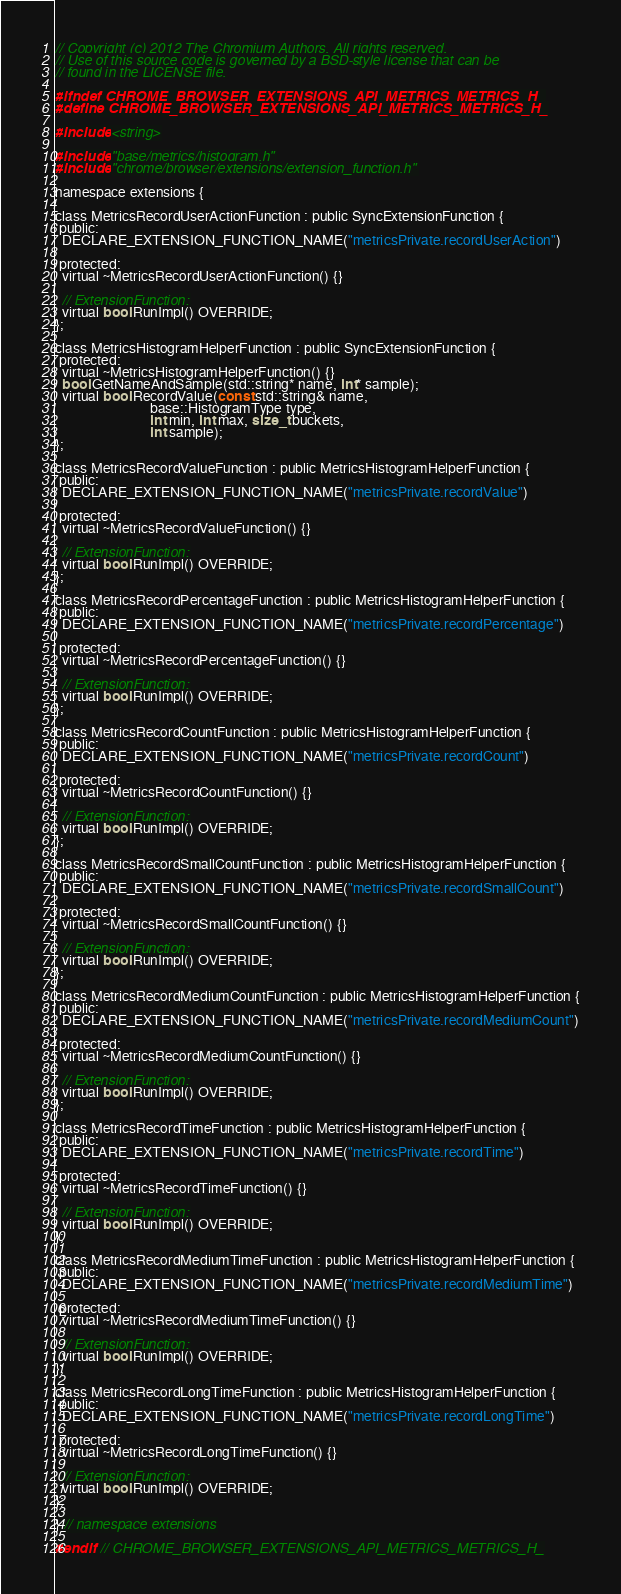Convert code to text. <code><loc_0><loc_0><loc_500><loc_500><_C_>// Copyright (c) 2012 The Chromium Authors. All rights reserved.
// Use of this source code is governed by a BSD-style license that can be
// found in the LICENSE file.

#ifndef CHROME_BROWSER_EXTENSIONS_API_METRICS_METRICS_H_
#define CHROME_BROWSER_EXTENSIONS_API_METRICS_METRICS_H_

#include <string>

#include "base/metrics/histogram.h"
#include "chrome/browser/extensions/extension_function.h"

namespace extensions {

class MetricsRecordUserActionFunction : public SyncExtensionFunction {
 public:
  DECLARE_EXTENSION_FUNCTION_NAME("metricsPrivate.recordUserAction")

 protected:
  virtual ~MetricsRecordUserActionFunction() {}

  // ExtensionFunction:
  virtual bool RunImpl() OVERRIDE;
};

class MetricsHistogramHelperFunction : public SyncExtensionFunction {
 protected:
  virtual ~MetricsHistogramHelperFunction() {}
  bool GetNameAndSample(std::string* name, int* sample);
  virtual bool RecordValue(const std::string& name,
                           base::HistogramType type,
                           int min, int max, size_t buckets,
                           int sample);
};

class MetricsRecordValueFunction : public MetricsHistogramHelperFunction {
 public:
  DECLARE_EXTENSION_FUNCTION_NAME("metricsPrivate.recordValue")

 protected:
  virtual ~MetricsRecordValueFunction() {}

  // ExtensionFunction:
  virtual bool RunImpl() OVERRIDE;
};

class MetricsRecordPercentageFunction : public MetricsHistogramHelperFunction {
 public:
  DECLARE_EXTENSION_FUNCTION_NAME("metricsPrivate.recordPercentage")

 protected:
  virtual ~MetricsRecordPercentageFunction() {}

  // ExtensionFunction:
  virtual bool RunImpl() OVERRIDE;
};

class MetricsRecordCountFunction : public MetricsHistogramHelperFunction {
 public:
  DECLARE_EXTENSION_FUNCTION_NAME("metricsPrivate.recordCount")

 protected:
  virtual ~MetricsRecordCountFunction() {}

  // ExtensionFunction:
  virtual bool RunImpl() OVERRIDE;
};

class MetricsRecordSmallCountFunction : public MetricsHistogramHelperFunction {
 public:
  DECLARE_EXTENSION_FUNCTION_NAME("metricsPrivate.recordSmallCount")

 protected:
  virtual ~MetricsRecordSmallCountFunction() {}

  // ExtensionFunction:
  virtual bool RunImpl() OVERRIDE;
};

class MetricsRecordMediumCountFunction : public MetricsHistogramHelperFunction {
 public:
  DECLARE_EXTENSION_FUNCTION_NAME("metricsPrivate.recordMediumCount")

 protected:
  virtual ~MetricsRecordMediumCountFunction() {}

  // ExtensionFunction:
  virtual bool RunImpl() OVERRIDE;
};

class MetricsRecordTimeFunction : public MetricsHistogramHelperFunction {
 public:
  DECLARE_EXTENSION_FUNCTION_NAME("metricsPrivate.recordTime")

 protected:
  virtual ~MetricsRecordTimeFunction() {}

  // ExtensionFunction:
  virtual bool RunImpl() OVERRIDE;
};

class MetricsRecordMediumTimeFunction : public MetricsHistogramHelperFunction {
 public:
  DECLARE_EXTENSION_FUNCTION_NAME("metricsPrivate.recordMediumTime")

 protected:
  virtual ~MetricsRecordMediumTimeFunction() {}

  // ExtensionFunction:
  virtual bool RunImpl() OVERRIDE;
};

class MetricsRecordLongTimeFunction : public MetricsHistogramHelperFunction {
 public:
  DECLARE_EXTENSION_FUNCTION_NAME("metricsPrivate.recordLongTime")

 protected:
  virtual ~MetricsRecordLongTimeFunction() {}

  // ExtensionFunction:
  virtual bool RunImpl() OVERRIDE;
};

} // namespace extensions

#endif  // CHROME_BROWSER_EXTENSIONS_API_METRICS_METRICS_H_
</code> 